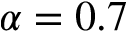<formula> <loc_0><loc_0><loc_500><loc_500>\alpha = 0 . 7</formula> 